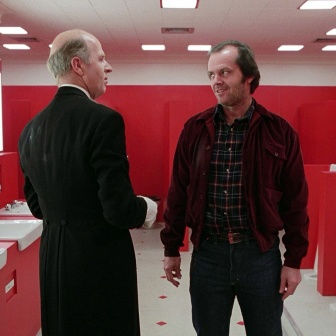What do you think is going on in this snapshot? In the image, two men are engaged in a conversation in a strikingly red bathroom. The man on the left, who is bald, is dressed in a black suit and seems to be explaining something to the man on the right. The man on the right, sporting a beard and a smile, is wearing a red jacket paired with blue jeans. The bathroom fixtures, all in red, fill the background, and the floor is covered in red tiles. The men, standing in the center of the image, seem to be the focal point of this scene and might be discussing something significant or having an intense conversation. 